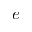Convert formula to latex. <formula><loc_0><loc_0><loc_500><loc_500>e</formula> 